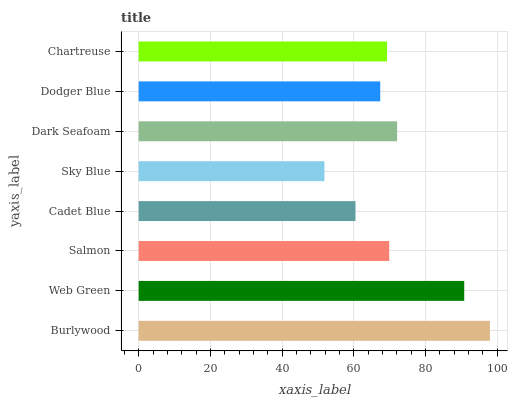Is Sky Blue the minimum?
Answer yes or no. Yes. Is Burlywood the maximum?
Answer yes or no. Yes. Is Web Green the minimum?
Answer yes or no. No. Is Web Green the maximum?
Answer yes or no. No. Is Burlywood greater than Web Green?
Answer yes or no. Yes. Is Web Green less than Burlywood?
Answer yes or no. Yes. Is Web Green greater than Burlywood?
Answer yes or no. No. Is Burlywood less than Web Green?
Answer yes or no. No. Is Salmon the high median?
Answer yes or no. Yes. Is Chartreuse the low median?
Answer yes or no. Yes. Is Burlywood the high median?
Answer yes or no. No. Is Burlywood the low median?
Answer yes or no. No. 